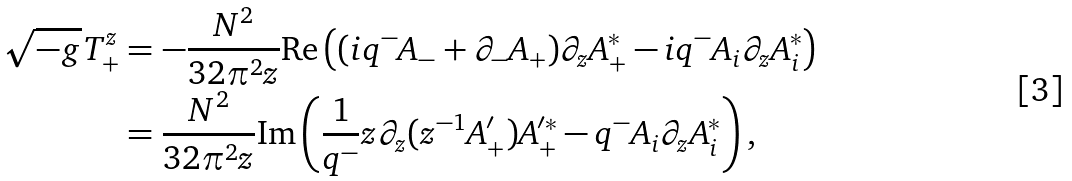Convert formula to latex. <formula><loc_0><loc_0><loc_500><loc_500>\sqrt { - g } T _ { + } ^ { z } & = - \frac { N ^ { 2 } } { 3 2 \pi ^ { 2 } z } \text {Re} \left ( ( i q ^ { - } A _ { - } + \partial _ { - } A _ { + } ) \partial _ { z } A _ { + } ^ { * } - i q ^ { - } A _ { i } \partial _ { z } A _ { i } ^ { * } \right ) \\ & = \frac { N ^ { 2 } } { 3 2 \pi ^ { 2 } z } \text {Im} \left ( \frac { 1 } { q ^ { - } } z \partial _ { z } ( z ^ { - 1 } A ^ { \prime } _ { + } ) A _ { + } ^ { \prime * } - q ^ { - } A _ { i } \partial _ { z } A _ { i } ^ { * } \right ) ,</formula> 